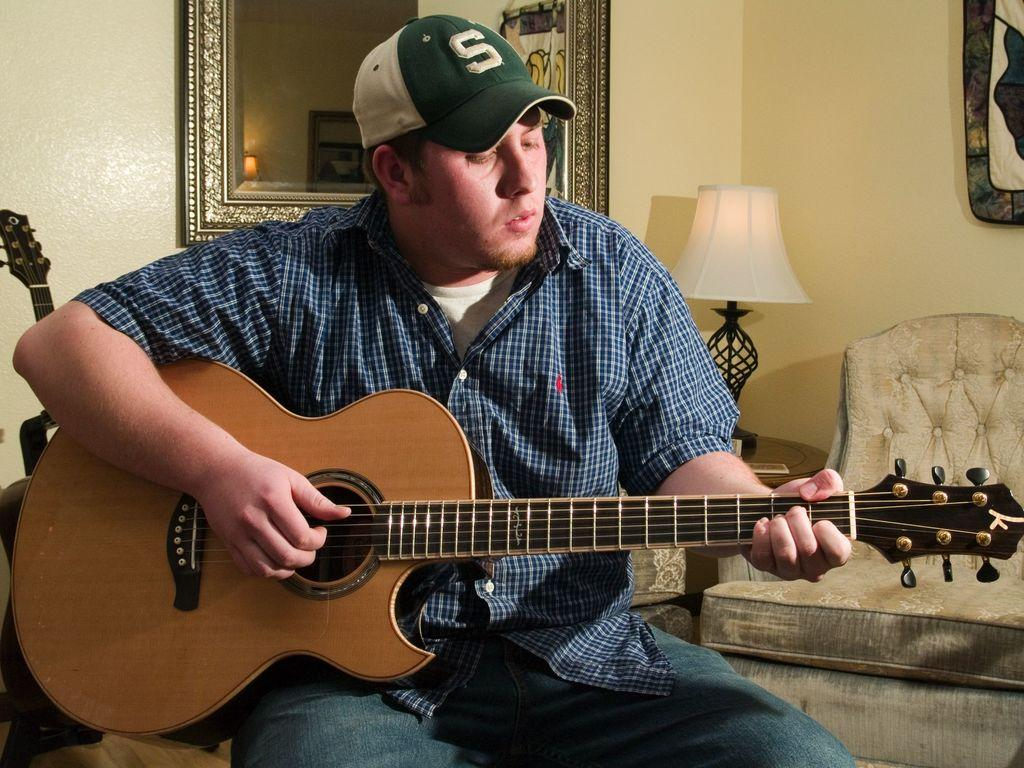What is the man in the image doing? The man is playing the guitar. What is the man holding in the image? The man is holding a guitar. Where is the man sitting in the image? The man is sitting on a sofa. What can be seen in the background of the image? There is a sofa and a table lamp in the background of the image. What language is the man speaking while playing the guitar in the image? There is no indication of the man speaking any language in the image, as the focus is on him playing the guitar. --- 